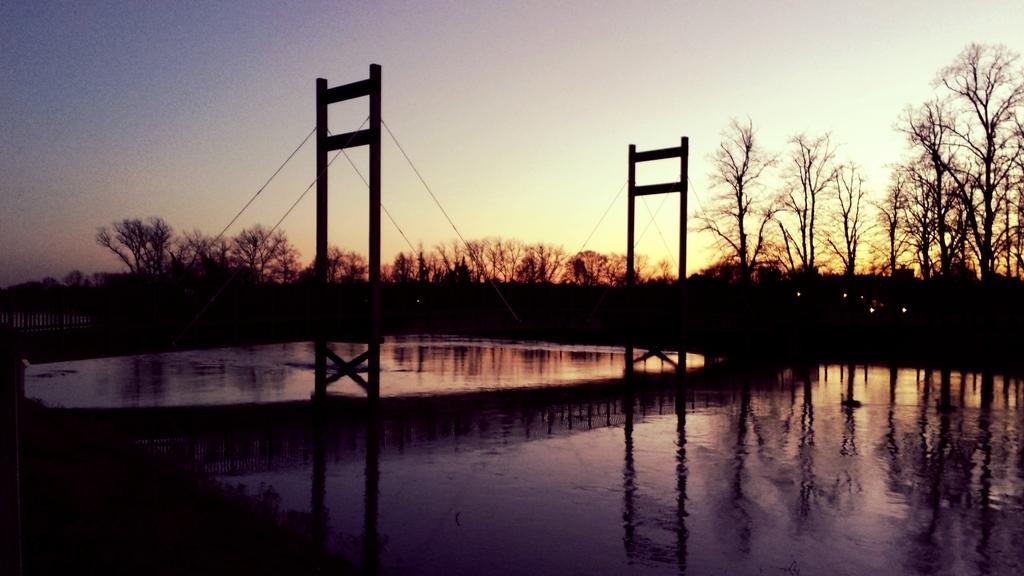How would you summarize this image in a sentence or two? In this image in the middle of the water body there is a bridge. In the background there are trees. The sky is clear. 